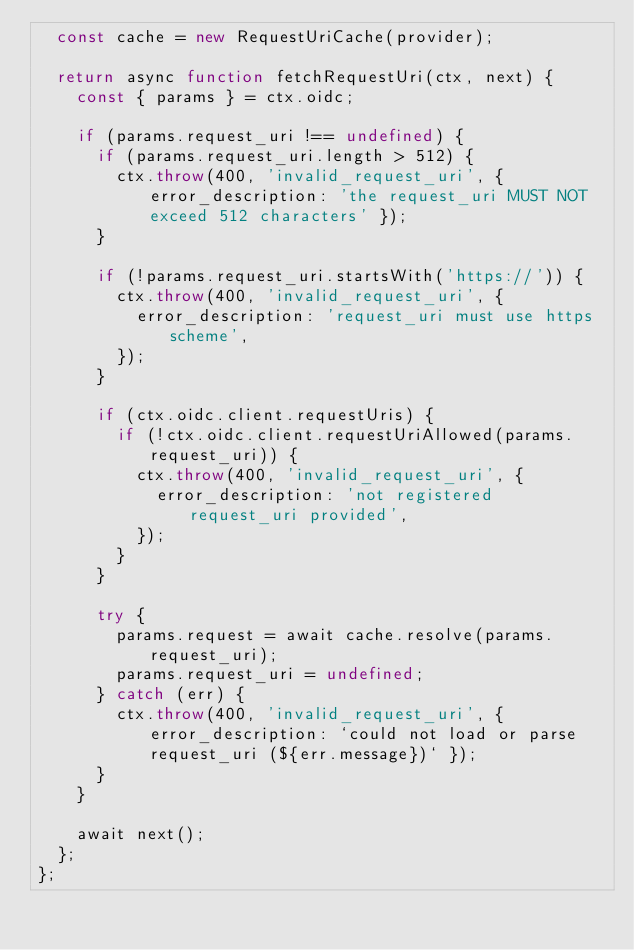<code> <loc_0><loc_0><loc_500><loc_500><_JavaScript_>  const cache = new RequestUriCache(provider);

  return async function fetchRequestUri(ctx, next) {
    const { params } = ctx.oidc;

    if (params.request_uri !== undefined) {
      if (params.request_uri.length > 512) {
        ctx.throw(400, 'invalid_request_uri', { error_description: 'the request_uri MUST NOT exceed 512 characters' });
      }

      if (!params.request_uri.startsWith('https://')) {
        ctx.throw(400, 'invalid_request_uri', {
          error_description: 'request_uri must use https scheme',
        });
      }

      if (ctx.oidc.client.requestUris) {
        if (!ctx.oidc.client.requestUriAllowed(params.request_uri)) {
          ctx.throw(400, 'invalid_request_uri', {
            error_description: 'not registered request_uri provided',
          });
        }
      }

      try {
        params.request = await cache.resolve(params.request_uri);
        params.request_uri = undefined;
      } catch (err) {
        ctx.throw(400, 'invalid_request_uri', { error_description: `could not load or parse request_uri (${err.message})` });
      }
    }

    await next();
  };
};
</code> 